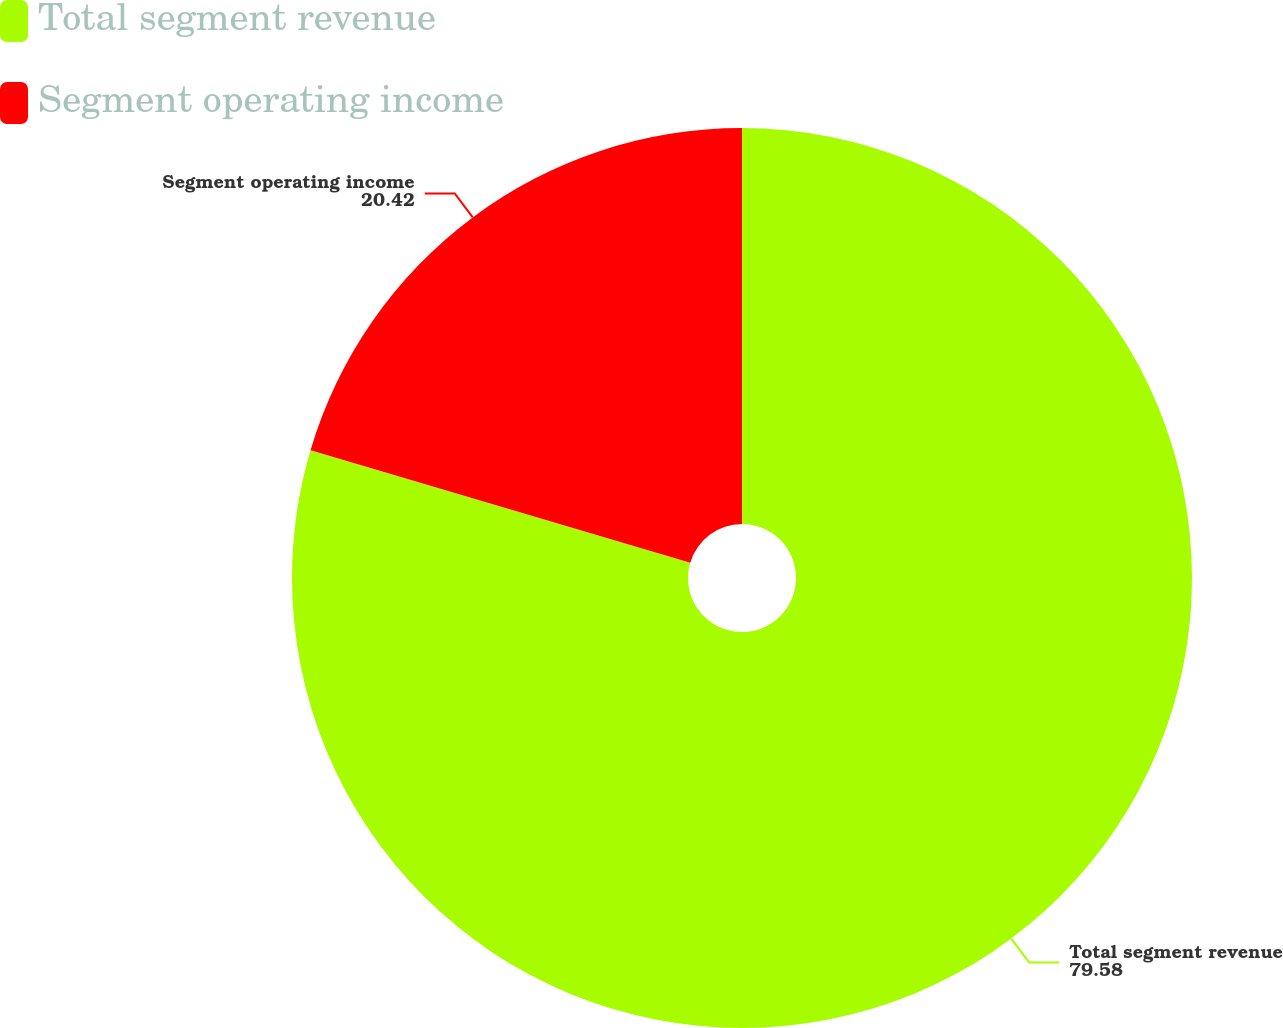<chart> <loc_0><loc_0><loc_500><loc_500><pie_chart><fcel>Total segment revenue<fcel>Segment operating income<nl><fcel>79.58%<fcel>20.42%<nl></chart> 